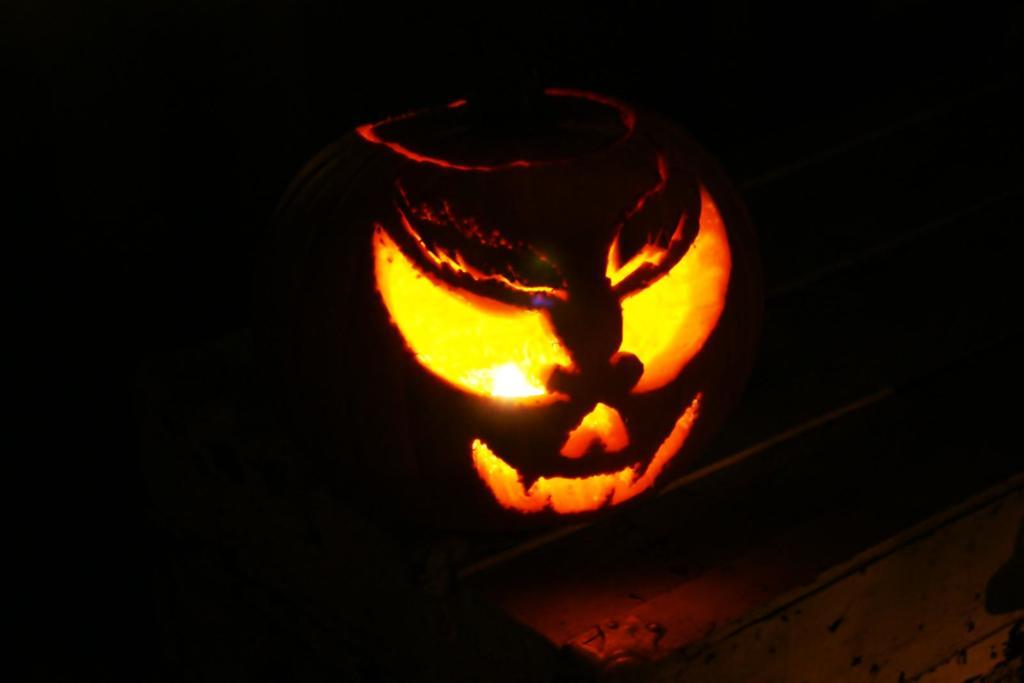What is the overall color scheme of the image? The background of the image is dark. What is the main object in the image? There is a carved pumpkin in the image. Is there any source of light in the image? Yes, a light is visible in the image. What can be found at the bottom portion of the image? There is an object at the bottom portion of the image. How many kittens are playing with the marble in the image? There are no kittens or marbles present in the image. What type of branch is visible in the image? There is no branch visible in the image; it features a carved pumpkin and a light source. 